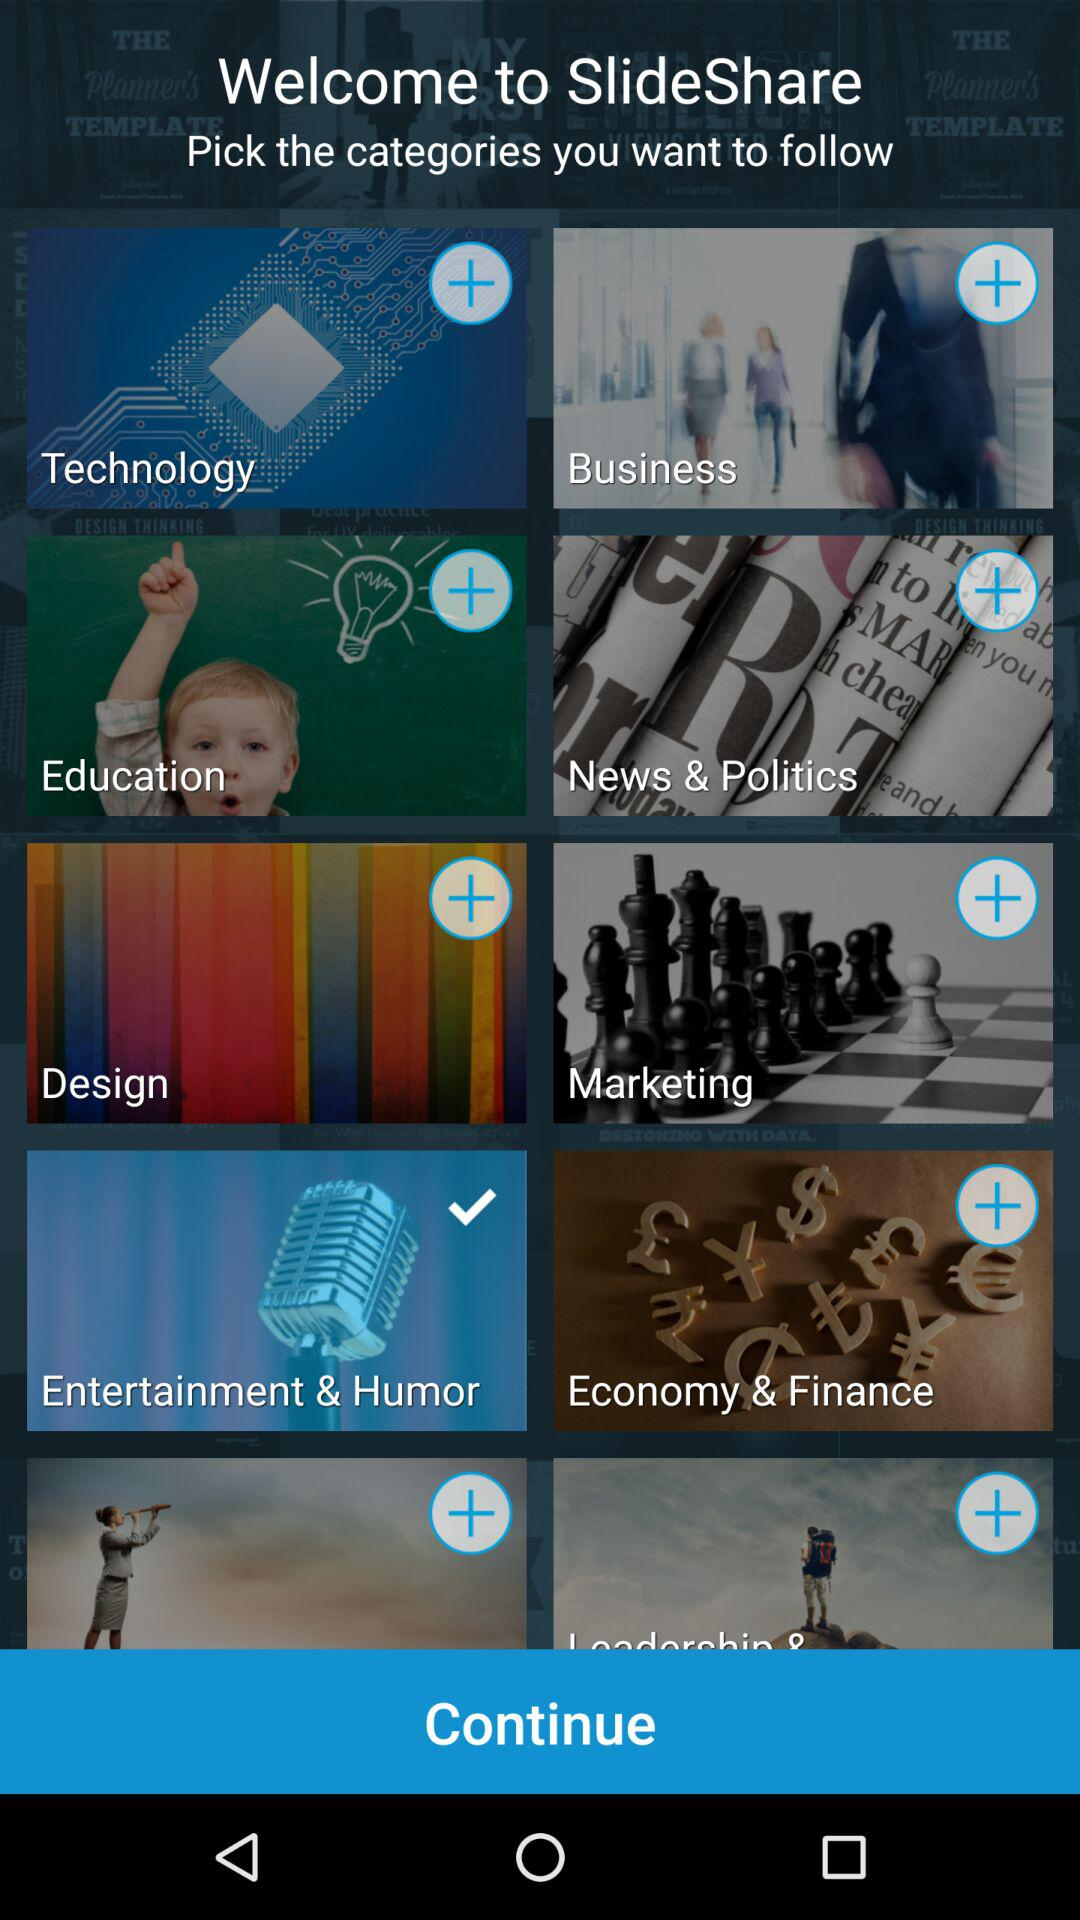Which is the selected category? The selected category is "Entertainment & Humor". 